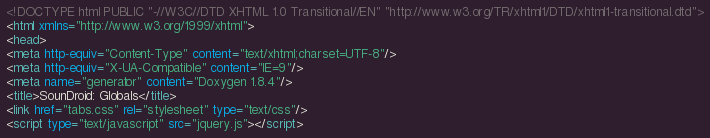Convert code to text. <code><loc_0><loc_0><loc_500><loc_500><_HTML_><!DOCTYPE html PUBLIC "-//W3C//DTD XHTML 1.0 Transitional//EN" "http://www.w3.org/TR/xhtml1/DTD/xhtml1-transitional.dtd">
<html xmlns="http://www.w3.org/1999/xhtml">
<head>
<meta http-equiv="Content-Type" content="text/xhtml;charset=UTF-8"/>
<meta http-equiv="X-UA-Compatible" content="IE=9"/>
<meta name="generator" content="Doxygen 1.8.4"/>
<title>SounDroid: Globals</title>
<link href="tabs.css" rel="stylesheet" type="text/css"/>
<script type="text/javascript" src="jquery.js"></script></code> 